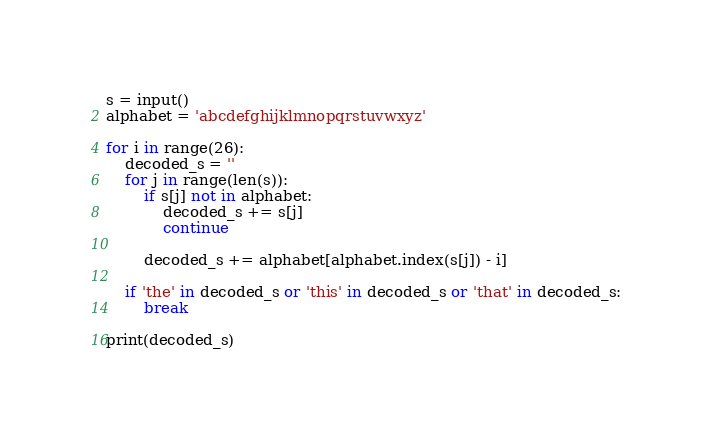<code> <loc_0><loc_0><loc_500><loc_500><_Python_>s = input()
alphabet = 'abcdefghijklmnopqrstuvwxyz'

for i in range(26):
    decoded_s = ''
    for j in range(len(s)):
        if s[j] not in alphabet:
            decoded_s += s[j]
            continue

        decoded_s += alphabet[alphabet.index(s[j]) - i]

    if 'the' in decoded_s or 'this' in decoded_s or 'that' in decoded_s:
        break

print(decoded_s)</code> 